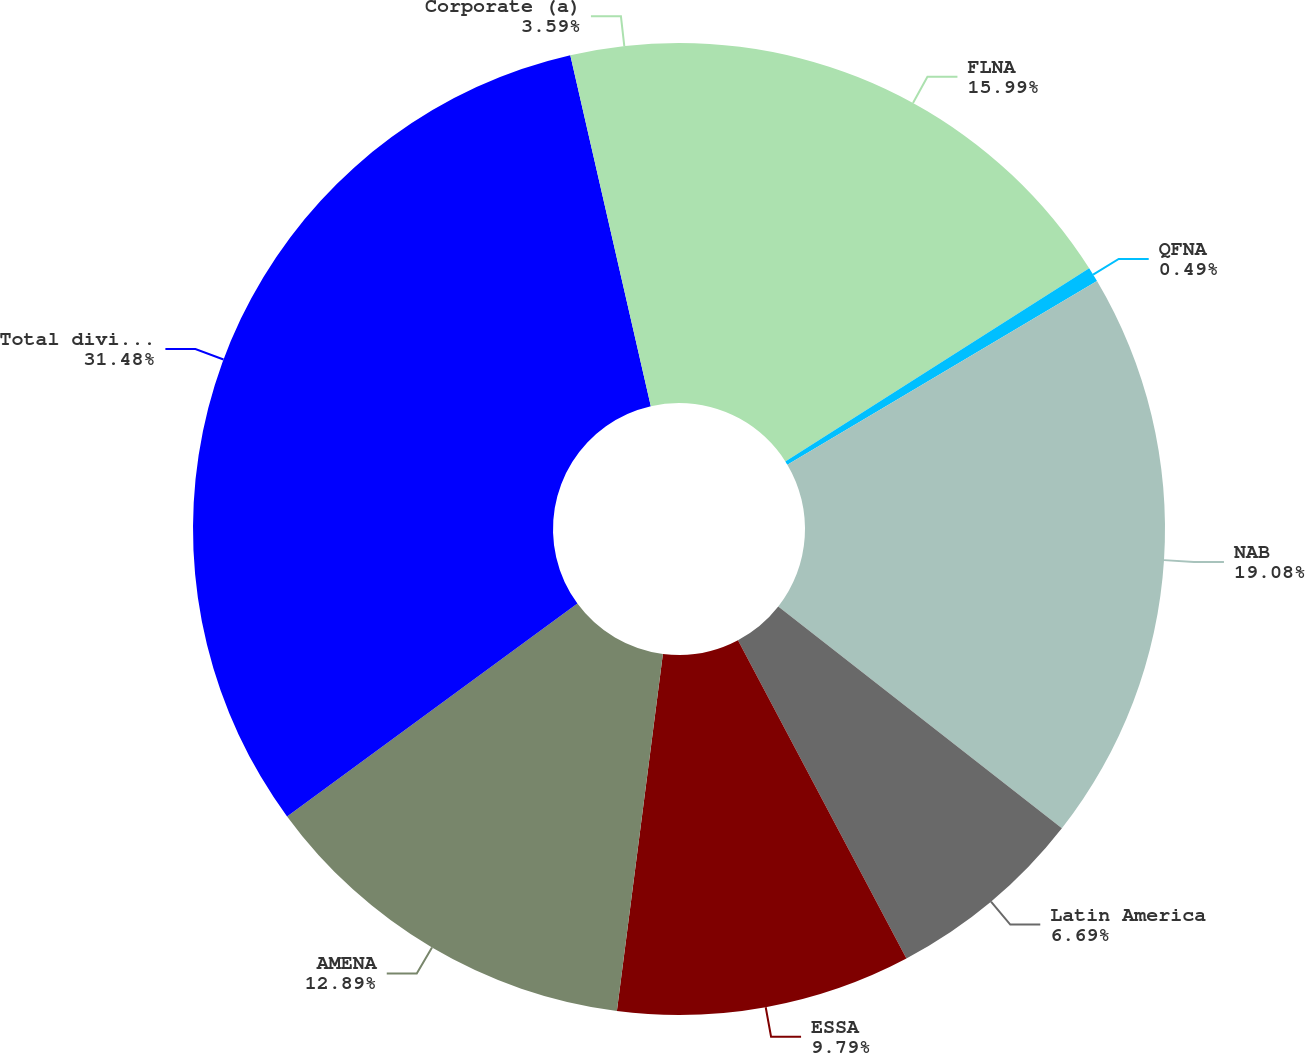<chart> <loc_0><loc_0><loc_500><loc_500><pie_chart><fcel>FLNA<fcel>QFNA<fcel>NAB<fcel>Latin America<fcel>ESSA<fcel>AMENA<fcel>Total division<fcel>Corporate (a)<nl><fcel>15.99%<fcel>0.49%<fcel>19.08%<fcel>6.69%<fcel>9.79%<fcel>12.89%<fcel>31.48%<fcel>3.59%<nl></chart> 